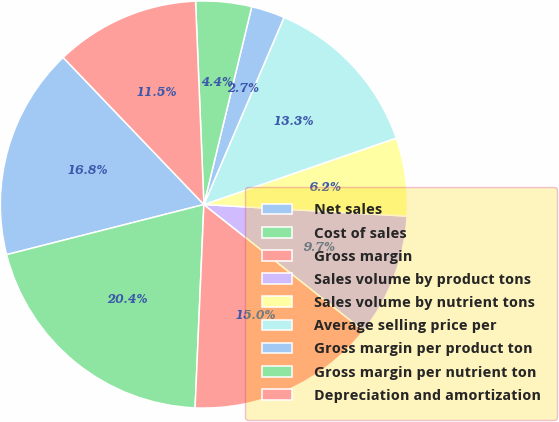Convert chart. <chart><loc_0><loc_0><loc_500><loc_500><pie_chart><fcel>Net sales<fcel>Cost of sales<fcel>Gross margin<fcel>Sales volume by product tons<fcel>Sales volume by nutrient tons<fcel>Average selling price per<fcel>Gross margin per product ton<fcel>Gross margin per nutrient ton<fcel>Depreciation and amortization<nl><fcel>16.81%<fcel>20.35%<fcel>15.04%<fcel>9.74%<fcel>6.2%<fcel>13.27%<fcel>2.66%<fcel>4.43%<fcel>11.5%<nl></chart> 